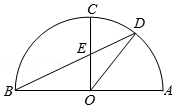As shown in the figure, in semicircle O with AB as the diameter, AC=BC. Point D is a point on AC. Connect OC. BD intersects at point E. Connect OD. If angle DEC = 65°, then the degree of angle DOC is ().
Choices:
A: 25°
B: 32.5°
C: 35°
D: 40° Upon examining the semicircle O with AB as the diameter, where AC equals BC, it indicates that triangle ABC is isosceles with the apex at C. When OC is drawn, it bisects angle ACB, producing two right angles since it stands on a diameter. With OC serving as the bisector, angle OEB is congruent to angle DEC, each measuring 65 degrees. Consequently, angle OBD, the complement to angle OEB in the 90-degree angle OBC, is 25 degrees. Recognizing that OD is a straight line, angle AOD is twice the angle ABD by the Inscribed Angle Theorem, totaling 50 degrees (2 * 25 degrees = 50 degrees). Finally, subtracting angle AOD from the right angle in BOC (90 degrees), we find that angle DOC measures 40 degrees. Therefore, the answer to the degree of angle DOC is D: 40°. 